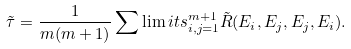<formula> <loc_0><loc_0><loc_500><loc_500>\tilde { \tau } = \frac { 1 } { m ( m + 1 ) } \sum \lim i t s _ { i , j = 1 } ^ { m + 1 } \tilde { R } ( E _ { i } , E _ { j } , E _ { j } , E _ { i } ) .</formula> 